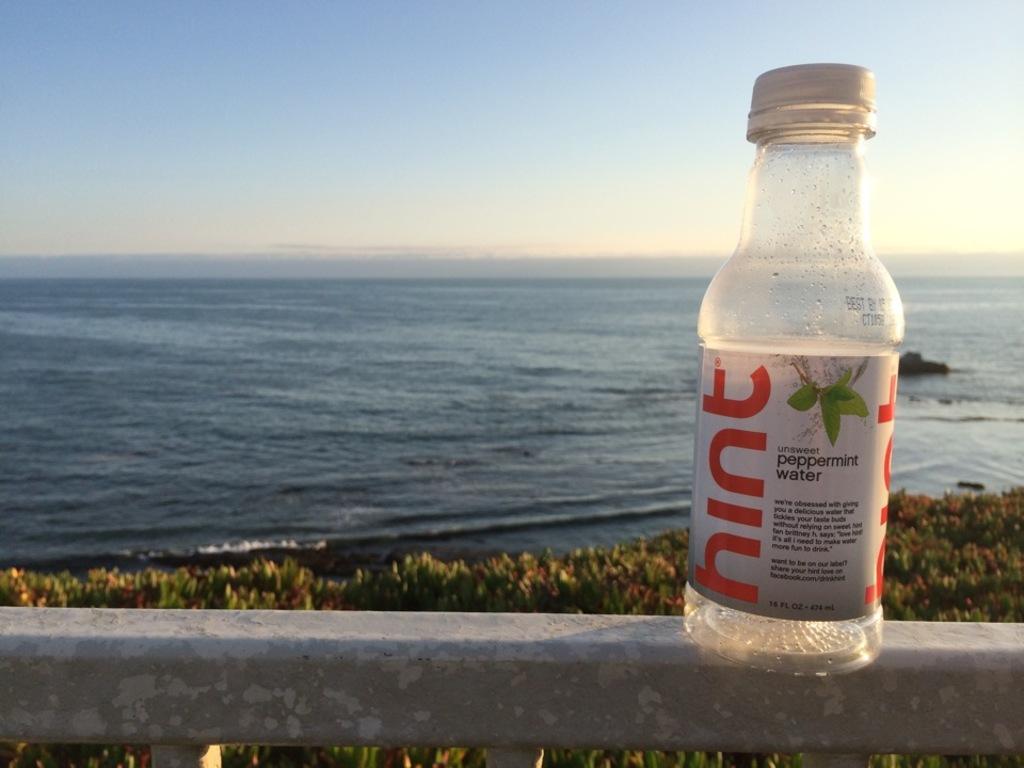How would you summarize this image in a sentence or two? on the wall there is a bottle with label on it. In the background there is a sea and in front there are plants. On top there is a blue sky. 